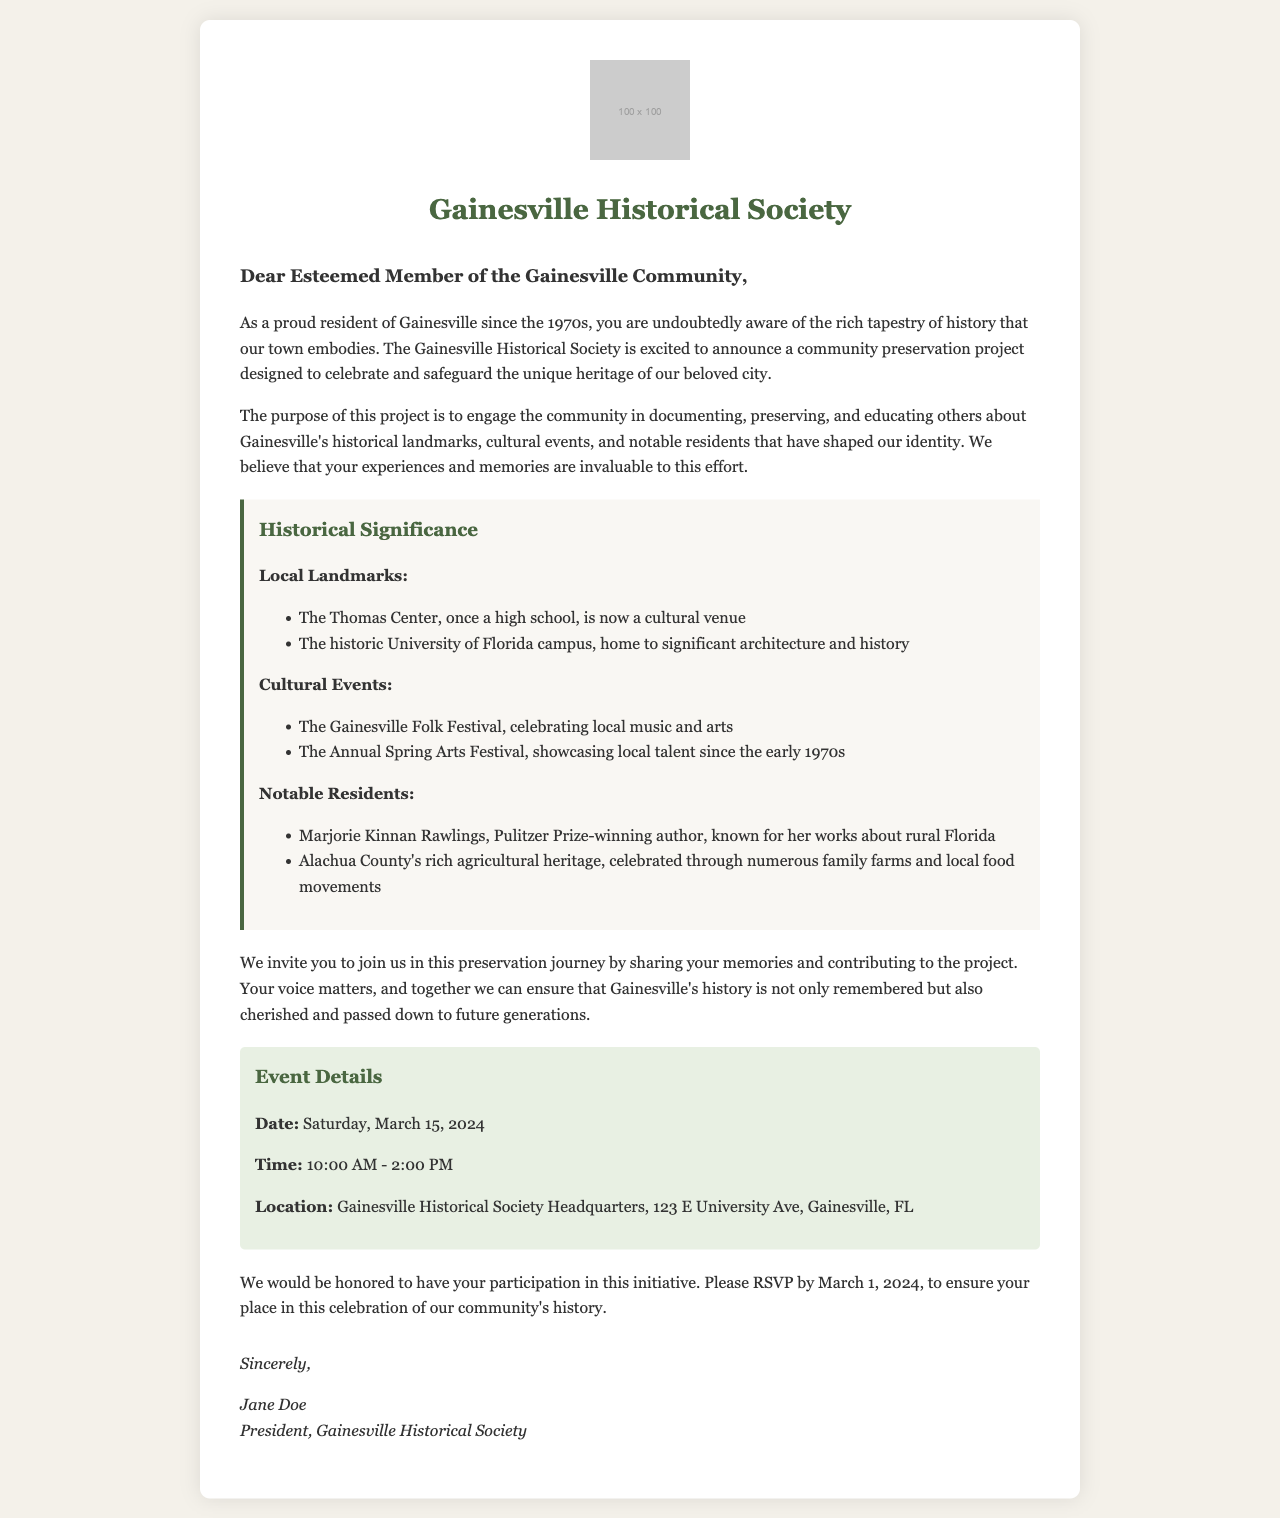What is the date of the event? The document specifies the date of the community preservation project event as Saturday, March 15, 2024.
Answer: Saturday, March 15, 2024 What time does the event start? According to the document, the event starts at 10:00 AM.
Answer: 10:00 AM Where is the event located? The document provides the location of the event as Gainesville Historical Society Headquarters, 123 E University Ave, Gainesville, FL.
Answer: Gainesville Historical Society Headquarters, 123 E University Ave, Gainesville, FL Who is the president of the Gainesville Historical Society? The letter is signed by Jane Doe, who is identified as the president of the Gainesville Historical Society.
Answer: Jane Doe What is the purpose of the community preservation project? The document states that the project aims to engage the community in documenting, preserving, and educating others about Gainesville's historical landmarks and events.
Answer: Documenting, preserving, and educating Why are personal memories important for this project? The document indicates that the experiences and memories of community members are considered invaluable to the preservation effort.
Answer: Invaluable How many notable residents are mentioned? The document lists two notable residents, Marjorie Kinnan Rawlings and Alachua County's agricultural heritage.
Answer: Two What is the RSVP deadline for the event? The document specifies that RSVPs should be made by March 1, 2024.
Answer: March 1, 2024 